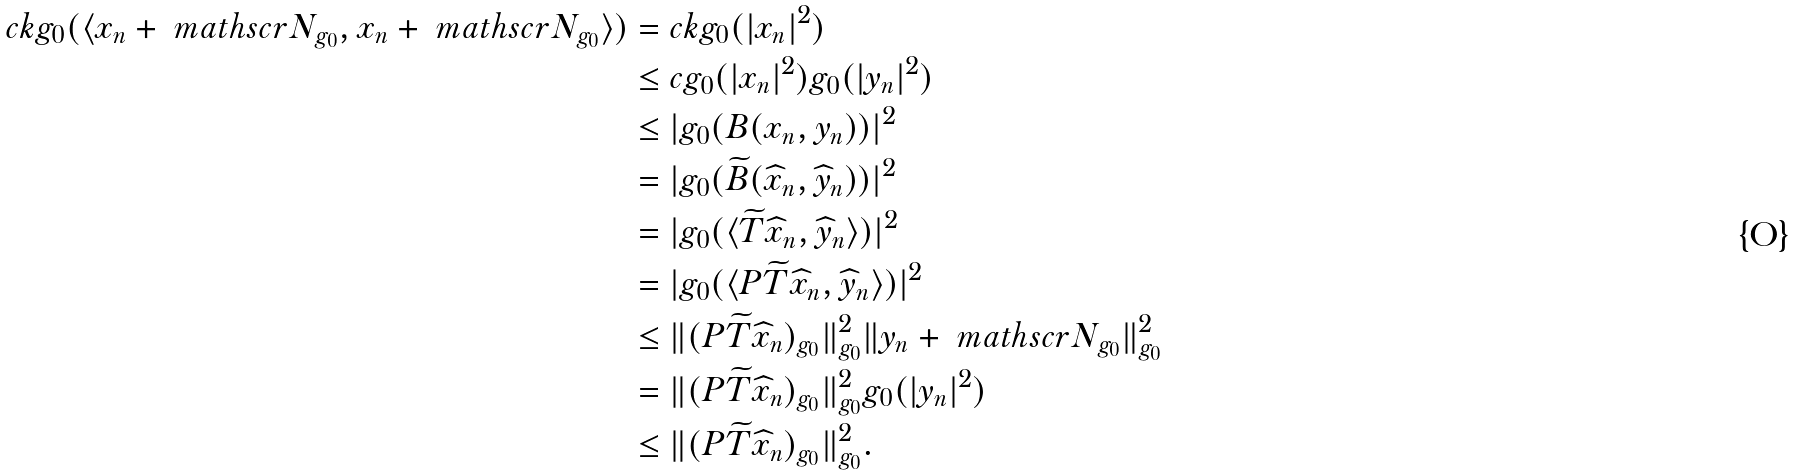<formula> <loc_0><loc_0><loc_500><loc_500>c k g _ { 0 } ( \langle x _ { n } + \ m a t h s c r N _ { g _ { 0 } } , x _ { n } + \ m a t h s c r N _ { g _ { 0 } } \rangle ) & = c k g _ { 0 } ( | x _ { n } | ^ { 2 } ) \\ & \leq c g _ { 0 } ( | x _ { n } | ^ { 2 } ) g _ { 0 } ( | y _ { n } | ^ { 2 } ) \\ & \leq | g _ { 0 } ( B ( x _ { n } , y _ { n } ) ) | ^ { 2 } \\ & = | g _ { 0 } ( \widetilde { B } ( \widehat { x } _ { n } , \widehat { y } _ { n } ) ) | ^ { 2 } \\ & = | g _ { 0 } ( \langle \widetilde { T } \widehat { x } _ { n } , \widehat { y } _ { n } \rangle ) | ^ { 2 } \\ & = | g _ { 0 } ( \langle P \widetilde { T } \widehat { x } _ { n } , \widehat { y } _ { n } \rangle ) | ^ { 2 } \\ & \leq \| ( P \widetilde { T } \widehat { x } _ { n } ) _ { g _ { 0 } } \| _ { g _ { 0 } } ^ { 2 } \| y _ { n } + \ m a t h s c r N _ { g _ { 0 } } \| _ { g _ { 0 } } ^ { 2 } \\ & = \| ( P \widetilde { T } \widehat { x } _ { n } ) _ { g _ { 0 } } \| _ { g _ { 0 } } ^ { 2 } g _ { 0 } ( | y _ { n } | ^ { 2 } ) \\ & \leq \| ( P \widetilde { T } \widehat { x } _ { n } ) _ { g _ { 0 } } \| _ { g _ { 0 } } ^ { 2 } .</formula> 